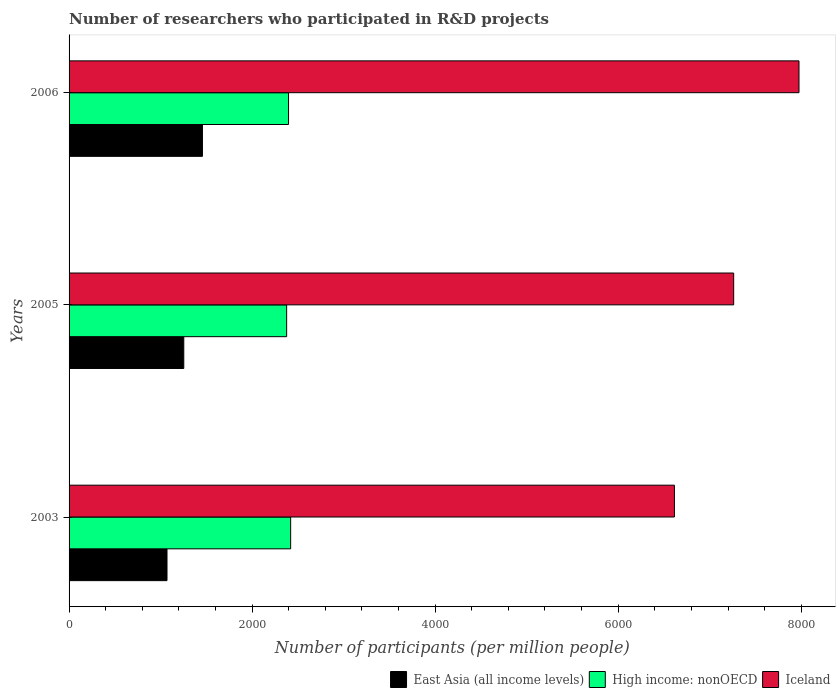Are the number of bars per tick equal to the number of legend labels?
Keep it short and to the point. Yes. How many bars are there on the 1st tick from the bottom?
Offer a terse response. 3. What is the label of the 2nd group of bars from the top?
Make the answer very short. 2005. What is the number of researchers who participated in R&D projects in East Asia (all income levels) in 2003?
Give a very brief answer. 1070.1. Across all years, what is the maximum number of researchers who participated in R&D projects in Iceland?
Give a very brief answer. 7975.62. Across all years, what is the minimum number of researchers who participated in R&D projects in High income: nonOECD?
Your answer should be compact. 2377.3. In which year was the number of researchers who participated in R&D projects in Iceland maximum?
Make the answer very short. 2006. In which year was the number of researchers who participated in R&D projects in East Asia (all income levels) minimum?
Provide a short and direct response. 2003. What is the total number of researchers who participated in R&D projects in East Asia (all income levels) in the graph?
Make the answer very short. 3780.72. What is the difference between the number of researchers who participated in R&D projects in East Asia (all income levels) in 2005 and that in 2006?
Make the answer very short. -203.78. What is the difference between the number of researchers who participated in R&D projects in Iceland in 2005 and the number of researchers who participated in R&D projects in High income: nonOECD in 2003?
Provide a short and direct response. 4840.57. What is the average number of researchers who participated in R&D projects in Iceland per year?
Your answer should be very brief. 7283.92. In the year 2003, what is the difference between the number of researchers who participated in R&D projects in Iceland and number of researchers who participated in R&D projects in East Asia (all income levels)?
Give a very brief answer. 5544.26. What is the ratio of the number of researchers who participated in R&D projects in High income: nonOECD in 2003 to that in 2005?
Provide a succinct answer. 1.02. Is the number of researchers who participated in R&D projects in High income: nonOECD in 2003 less than that in 2006?
Your answer should be very brief. No. Is the difference between the number of researchers who participated in R&D projects in Iceland in 2005 and 2006 greater than the difference between the number of researchers who participated in R&D projects in East Asia (all income levels) in 2005 and 2006?
Keep it short and to the point. No. What is the difference between the highest and the second highest number of researchers who participated in R&D projects in Iceland?
Offer a terse response. 713.83. What is the difference between the highest and the lowest number of researchers who participated in R&D projects in Iceland?
Give a very brief answer. 1361.26. Is the sum of the number of researchers who participated in R&D projects in Iceland in 2003 and 2005 greater than the maximum number of researchers who participated in R&D projects in High income: nonOECD across all years?
Offer a very short reply. Yes. What does the 3rd bar from the top in 2005 represents?
Ensure brevity in your answer.  East Asia (all income levels). Are the values on the major ticks of X-axis written in scientific E-notation?
Your response must be concise. No. How are the legend labels stacked?
Your answer should be compact. Horizontal. What is the title of the graph?
Ensure brevity in your answer.  Number of researchers who participated in R&D projects. Does "Low & middle income" appear as one of the legend labels in the graph?
Make the answer very short. No. What is the label or title of the X-axis?
Your answer should be compact. Number of participants (per million people). What is the label or title of the Y-axis?
Provide a succinct answer. Years. What is the Number of participants (per million people) of East Asia (all income levels) in 2003?
Your answer should be very brief. 1070.1. What is the Number of participants (per million people) in High income: nonOECD in 2003?
Keep it short and to the point. 2421.22. What is the Number of participants (per million people) of Iceland in 2003?
Offer a very short reply. 6614.36. What is the Number of participants (per million people) of East Asia (all income levels) in 2005?
Provide a succinct answer. 1253.42. What is the Number of participants (per million people) of High income: nonOECD in 2005?
Your answer should be very brief. 2377.3. What is the Number of participants (per million people) of Iceland in 2005?
Give a very brief answer. 7261.79. What is the Number of participants (per million people) of East Asia (all income levels) in 2006?
Ensure brevity in your answer.  1457.2. What is the Number of participants (per million people) of High income: nonOECD in 2006?
Keep it short and to the point. 2397.91. What is the Number of participants (per million people) in Iceland in 2006?
Ensure brevity in your answer.  7975.62. Across all years, what is the maximum Number of participants (per million people) in East Asia (all income levels)?
Offer a very short reply. 1457.2. Across all years, what is the maximum Number of participants (per million people) of High income: nonOECD?
Provide a short and direct response. 2421.22. Across all years, what is the maximum Number of participants (per million people) of Iceland?
Your answer should be compact. 7975.62. Across all years, what is the minimum Number of participants (per million people) in East Asia (all income levels)?
Your response must be concise. 1070.1. Across all years, what is the minimum Number of participants (per million people) of High income: nonOECD?
Your response must be concise. 2377.3. Across all years, what is the minimum Number of participants (per million people) of Iceland?
Your response must be concise. 6614.36. What is the total Number of participants (per million people) of East Asia (all income levels) in the graph?
Give a very brief answer. 3780.72. What is the total Number of participants (per million people) of High income: nonOECD in the graph?
Offer a very short reply. 7196.43. What is the total Number of participants (per million people) of Iceland in the graph?
Provide a short and direct response. 2.19e+04. What is the difference between the Number of participants (per million people) in East Asia (all income levels) in 2003 and that in 2005?
Provide a succinct answer. -183.32. What is the difference between the Number of participants (per million people) of High income: nonOECD in 2003 and that in 2005?
Offer a very short reply. 43.92. What is the difference between the Number of participants (per million people) of Iceland in 2003 and that in 2005?
Your response must be concise. -647.43. What is the difference between the Number of participants (per million people) of East Asia (all income levels) in 2003 and that in 2006?
Give a very brief answer. -387.1. What is the difference between the Number of participants (per million people) of High income: nonOECD in 2003 and that in 2006?
Your response must be concise. 23.31. What is the difference between the Number of participants (per million people) of Iceland in 2003 and that in 2006?
Provide a succinct answer. -1361.26. What is the difference between the Number of participants (per million people) of East Asia (all income levels) in 2005 and that in 2006?
Keep it short and to the point. -203.78. What is the difference between the Number of participants (per million people) in High income: nonOECD in 2005 and that in 2006?
Make the answer very short. -20.62. What is the difference between the Number of participants (per million people) in Iceland in 2005 and that in 2006?
Offer a very short reply. -713.83. What is the difference between the Number of participants (per million people) of East Asia (all income levels) in 2003 and the Number of participants (per million people) of High income: nonOECD in 2005?
Provide a succinct answer. -1307.2. What is the difference between the Number of participants (per million people) in East Asia (all income levels) in 2003 and the Number of participants (per million people) in Iceland in 2005?
Ensure brevity in your answer.  -6191.69. What is the difference between the Number of participants (per million people) in High income: nonOECD in 2003 and the Number of participants (per million people) in Iceland in 2005?
Keep it short and to the point. -4840.57. What is the difference between the Number of participants (per million people) in East Asia (all income levels) in 2003 and the Number of participants (per million people) in High income: nonOECD in 2006?
Ensure brevity in your answer.  -1327.82. What is the difference between the Number of participants (per million people) in East Asia (all income levels) in 2003 and the Number of participants (per million people) in Iceland in 2006?
Provide a succinct answer. -6905.52. What is the difference between the Number of participants (per million people) in High income: nonOECD in 2003 and the Number of participants (per million people) in Iceland in 2006?
Provide a succinct answer. -5554.4. What is the difference between the Number of participants (per million people) of East Asia (all income levels) in 2005 and the Number of participants (per million people) of High income: nonOECD in 2006?
Give a very brief answer. -1144.49. What is the difference between the Number of participants (per million people) of East Asia (all income levels) in 2005 and the Number of participants (per million people) of Iceland in 2006?
Keep it short and to the point. -6722.2. What is the difference between the Number of participants (per million people) of High income: nonOECD in 2005 and the Number of participants (per million people) of Iceland in 2006?
Your answer should be very brief. -5598.32. What is the average Number of participants (per million people) in East Asia (all income levels) per year?
Your response must be concise. 1260.24. What is the average Number of participants (per million people) in High income: nonOECD per year?
Keep it short and to the point. 2398.81. What is the average Number of participants (per million people) in Iceland per year?
Keep it short and to the point. 7283.92. In the year 2003, what is the difference between the Number of participants (per million people) of East Asia (all income levels) and Number of participants (per million people) of High income: nonOECD?
Your answer should be compact. -1351.12. In the year 2003, what is the difference between the Number of participants (per million people) in East Asia (all income levels) and Number of participants (per million people) in Iceland?
Provide a succinct answer. -5544.26. In the year 2003, what is the difference between the Number of participants (per million people) in High income: nonOECD and Number of participants (per million people) in Iceland?
Offer a very short reply. -4193.14. In the year 2005, what is the difference between the Number of participants (per million people) of East Asia (all income levels) and Number of participants (per million people) of High income: nonOECD?
Keep it short and to the point. -1123.88. In the year 2005, what is the difference between the Number of participants (per million people) of East Asia (all income levels) and Number of participants (per million people) of Iceland?
Offer a terse response. -6008.37. In the year 2005, what is the difference between the Number of participants (per million people) in High income: nonOECD and Number of participants (per million people) in Iceland?
Ensure brevity in your answer.  -4884.49. In the year 2006, what is the difference between the Number of participants (per million people) in East Asia (all income levels) and Number of participants (per million people) in High income: nonOECD?
Ensure brevity in your answer.  -940.72. In the year 2006, what is the difference between the Number of participants (per million people) of East Asia (all income levels) and Number of participants (per million people) of Iceland?
Your answer should be compact. -6518.42. In the year 2006, what is the difference between the Number of participants (per million people) in High income: nonOECD and Number of participants (per million people) in Iceland?
Ensure brevity in your answer.  -5577.7. What is the ratio of the Number of participants (per million people) of East Asia (all income levels) in 2003 to that in 2005?
Offer a very short reply. 0.85. What is the ratio of the Number of participants (per million people) of High income: nonOECD in 2003 to that in 2005?
Provide a short and direct response. 1.02. What is the ratio of the Number of participants (per million people) in Iceland in 2003 to that in 2005?
Your answer should be very brief. 0.91. What is the ratio of the Number of participants (per million people) of East Asia (all income levels) in 2003 to that in 2006?
Provide a succinct answer. 0.73. What is the ratio of the Number of participants (per million people) of High income: nonOECD in 2003 to that in 2006?
Provide a succinct answer. 1.01. What is the ratio of the Number of participants (per million people) of Iceland in 2003 to that in 2006?
Offer a terse response. 0.83. What is the ratio of the Number of participants (per million people) in East Asia (all income levels) in 2005 to that in 2006?
Your response must be concise. 0.86. What is the ratio of the Number of participants (per million people) in High income: nonOECD in 2005 to that in 2006?
Make the answer very short. 0.99. What is the ratio of the Number of participants (per million people) of Iceland in 2005 to that in 2006?
Your response must be concise. 0.91. What is the difference between the highest and the second highest Number of participants (per million people) of East Asia (all income levels)?
Your answer should be very brief. 203.78. What is the difference between the highest and the second highest Number of participants (per million people) of High income: nonOECD?
Make the answer very short. 23.31. What is the difference between the highest and the second highest Number of participants (per million people) in Iceland?
Your answer should be very brief. 713.83. What is the difference between the highest and the lowest Number of participants (per million people) of East Asia (all income levels)?
Give a very brief answer. 387.1. What is the difference between the highest and the lowest Number of participants (per million people) in High income: nonOECD?
Your answer should be very brief. 43.92. What is the difference between the highest and the lowest Number of participants (per million people) in Iceland?
Keep it short and to the point. 1361.26. 